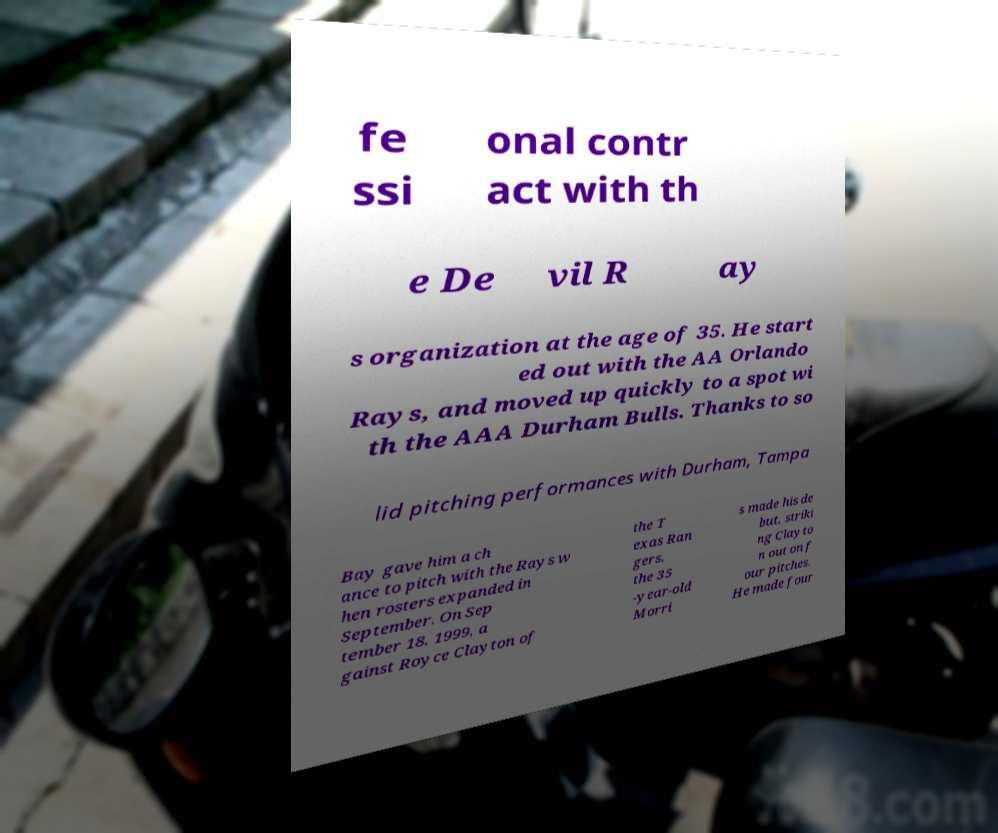What messages or text are displayed in this image? I need them in a readable, typed format. fe ssi onal contr act with th e De vil R ay s organization at the age of 35. He start ed out with the AA Orlando Rays, and moved up quickly to a spot wi th the AAA Durham Bulls. Thanks to so lid pitching performances with Durham, Tampa Bay gave him a ch ance to pitch with the Rays w hen rosters expanded in September. On Sep tember 18, 1999, a gainst Royce Clayton of the T exas Ran gers, the 35 -year-old Morri s made his de but, striki ng Clayto n out on f our pitches. He made four 